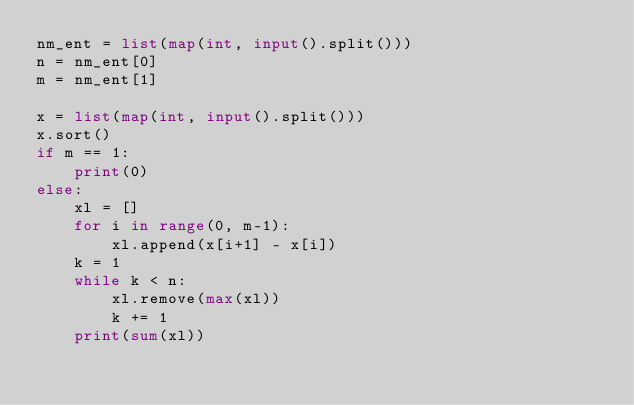Convert code to text. <code><loc_0><loc_0><loc_500><loc_500><_Python_>nm_ent = list(map(int, input().split()))
n = nm_ent[0]
m = nm_ent[1]

x = list(map(int, input().split()))
x.sort()
if m == 1:
    print(0)
else:
    xl = []
    for i in range(0, m-1):
        xl.append(x[i+1] - x[i])
    k = 1
    while k < n:
        xl.remove(max(xl))
        k += 1
    print(sum(xl))</code> 